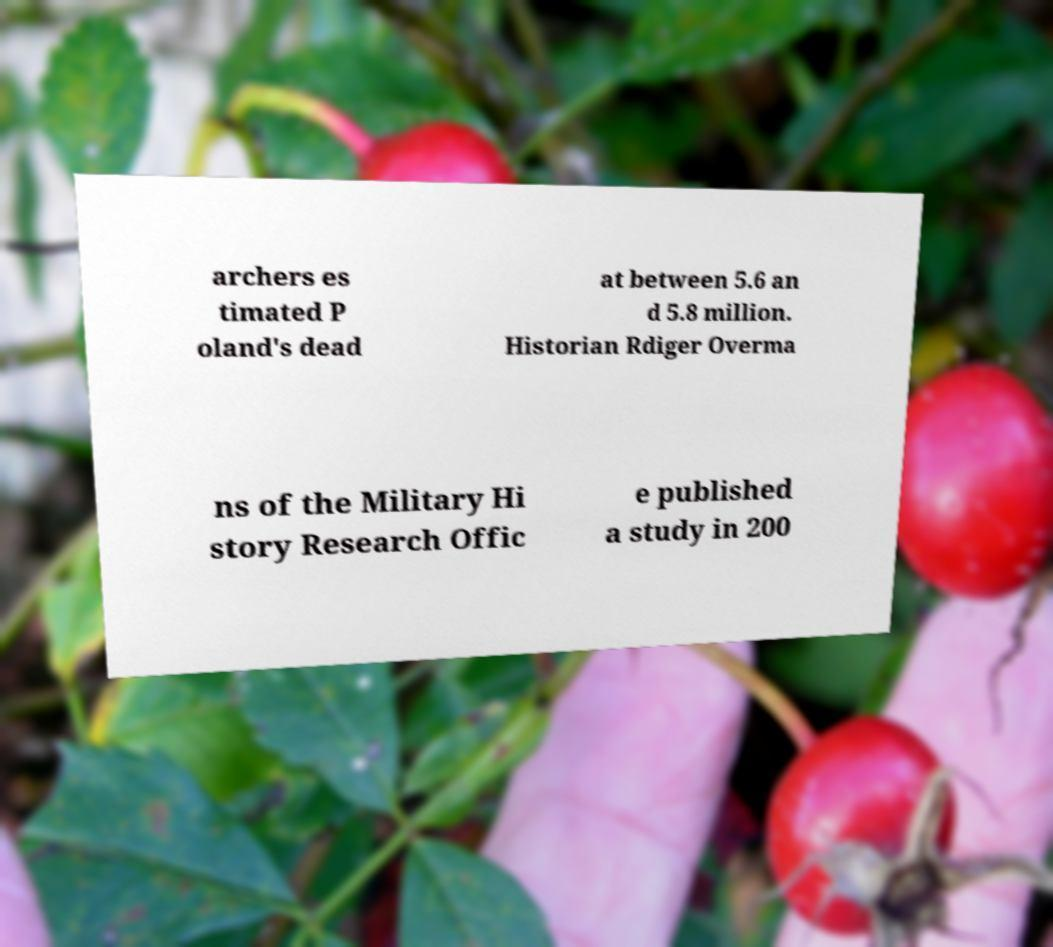There's text embedded in this image that I need extracted. Can you transcribe it verbatim? archers es timated P oland's dead at between 5.6 an d 5.8 million. Historian Rdiger Overma ns of the Military Hi story Research Offic e published a study in 200 